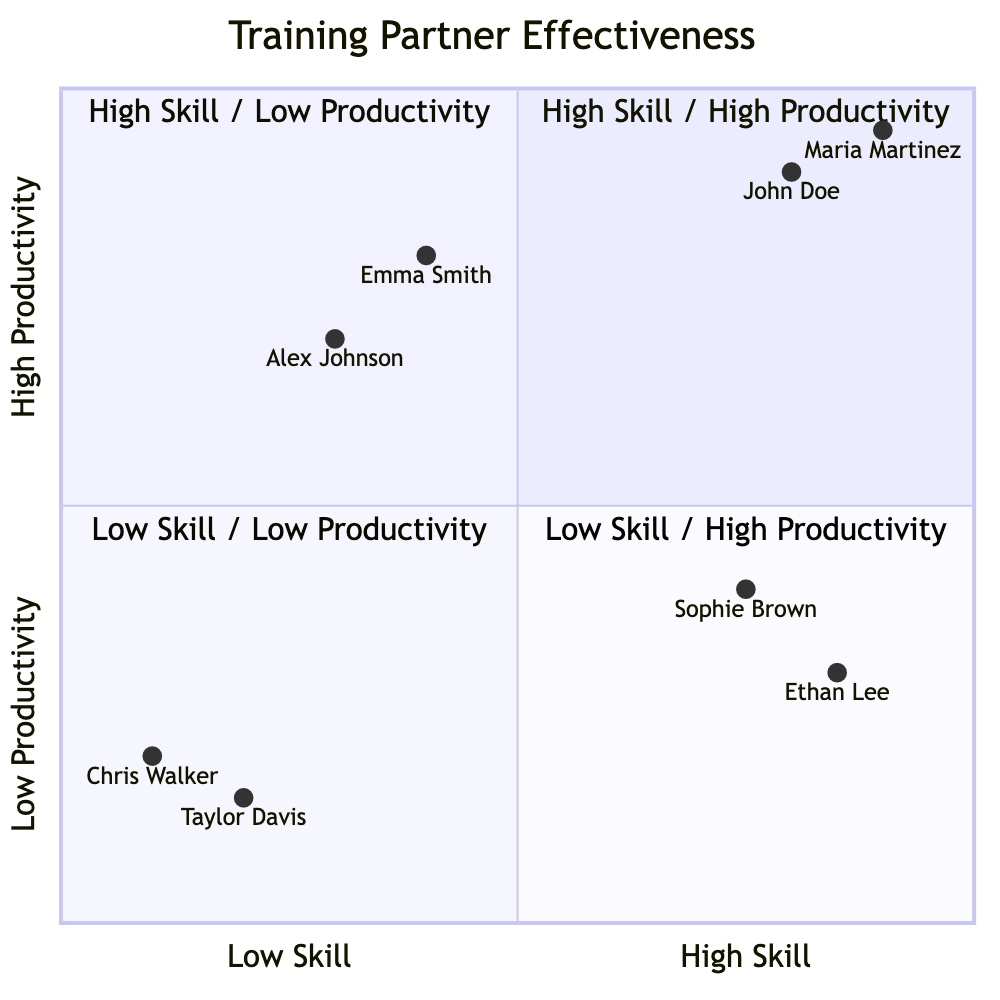What training partner ranks highest in both skill and productivity? The quadrant labeled "High Skill / High Productivity" contains John Doe and Maria Martinez. Among them, Maria Martinez has the highest productivity ranking of 0.95. Hence, Maria Martinez ranks highest.
Answer: Maria Martinez Which training partner is in the "Low Skill / High Productivity" quadrant? The quadrant named "Low Skill / High Productivity" lists Alex Johnson and Emma Smith. Therefore, Alex Johnson is one of the training partners located in this quadrant.
Answer: Alex Johnson How many partners fall into the "High Skill / Low Productivity" segment? The "High Skill / Low Productivity" quadrant includes two training partners, Ethan Lee and Sophie Brown. Thus, the count is two.
Answer: 2 What is the productivity score of Chris Walker? Chris Walker is positioned in the "Low Skill / Low Productivity" quadrant with a noted productivity score of 0.2, as stated in the diagram data.
Answer: 0.2 Which quadrant contains partners known for being less experienced but productive? The "Low Skill / High Productivity" quadrant contains partners like Alex Johnson and Emma Smith, both of whom are noted for being less experienced yet productive.
Answer: Low Skill / High Productivity What partner has the highest skill level in the "High Skill / Low Productivity" category? In the "High Skill / Low Productivity" quadrant, Ethan Lee has a skill level score of 0.85, making him the highest in skill within that category compared to Sophie Brown.
Answer: Ethan Lee What is the productivity score difference between John Doe and Maria Martinez? John Doe has a productivity score of 0.9, while Maria Martinez's is 0.95. The difference, then, is 0.95 - 0.9 = 0.05.
Answer: 0.05 Which partner has the lowest skill score in the diagram? Evaluating the skill scores, Chris Walker has the lowest skill score of 0.1, which places him at the bottom for skill level among all partners in the diagram.
Answer: Chris Walker 